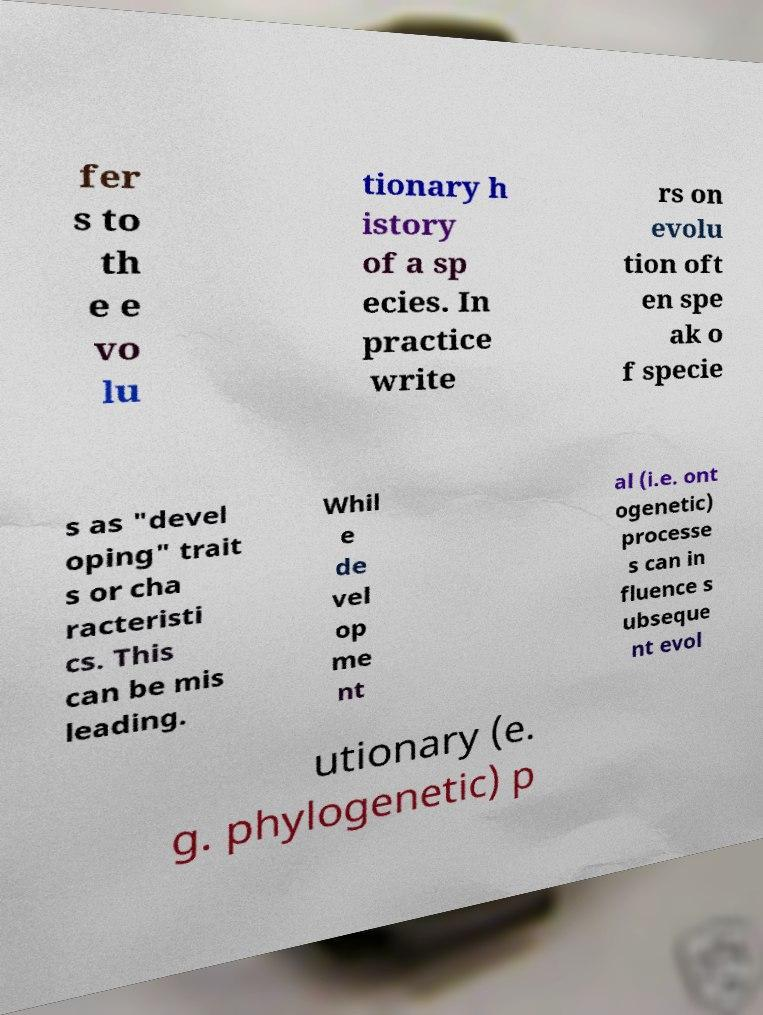Please read and relay the text visible in this image. What does it say? fer s to th e e vo lu tionary h istory of a sp ecies. In practice write rs on evolu tion oft en spe ak o f specie s as "devel oping" trait s or cha racteristi cs. This can be mis leading. Whil e de vel op me nt al (i.e. ont ogenetic) processe s can in fluence s ubseque nt evol utionary (e. g. phylogenetic) p 